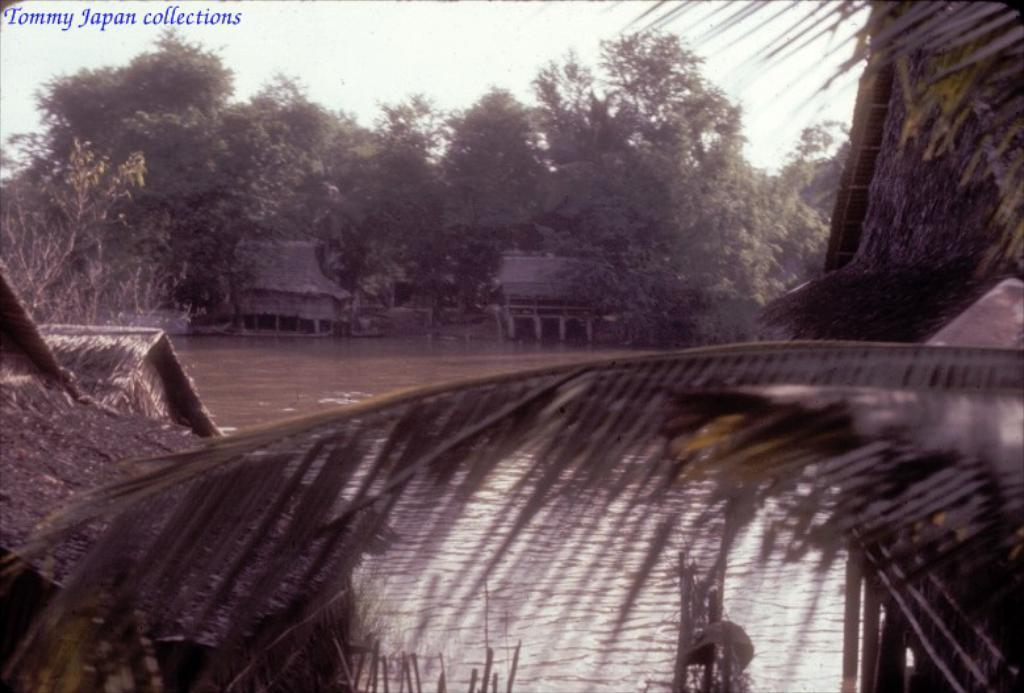What type of vegetation is present in the image? There are trees in the image. What type of structures can be seen in the image? There are huts in the image. What natural element is visible in the image? There is water visible in the image. What can be seen in the background of the image? The sky is visible in the background of the image. What color is the orange in the middle of the image? There is no orange present in the image. What discovery was made at the location depicted in the image? The image does not provide information about any discoveries made at the location. 